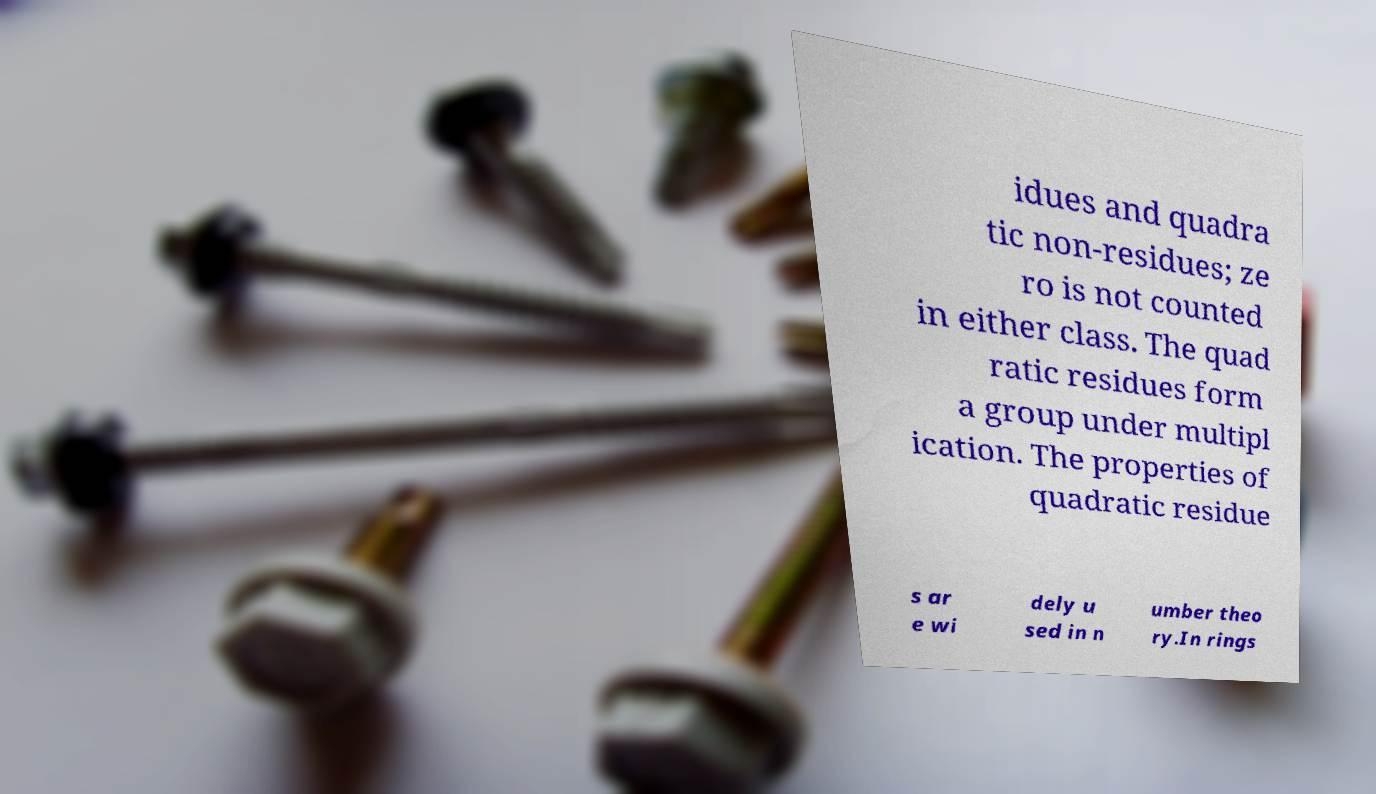Can you accurately transcribe the text from the provided image for me? idues and quadra tic non-residues; ze ro is not counted in either class. The quad ratic residues form a group under multipl ication. The properties of quadratic residue s ar e wi dely u sed in n umber theo ry.In rings 